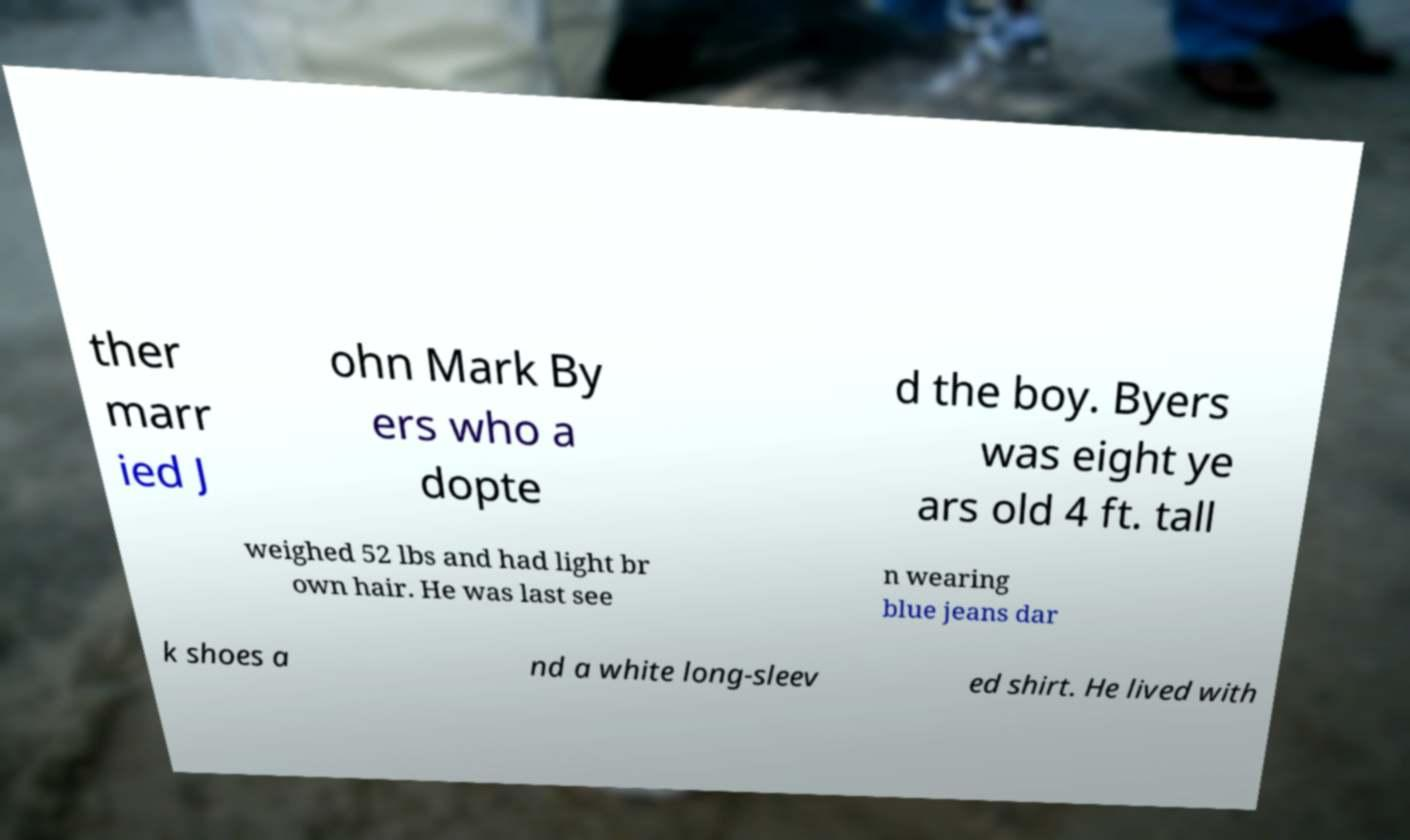Please read and relay the text visible in this image. What does it say? ther marr ied J ohn Mark By ers who a dopte d the boy. Byers was eight ye ars old 4 ft. tall weighed 52 lbs and had light br own hair. He was last see n wearing blue jeans dar k shoes a nd a white long-sleev ed shirt. He lived with 